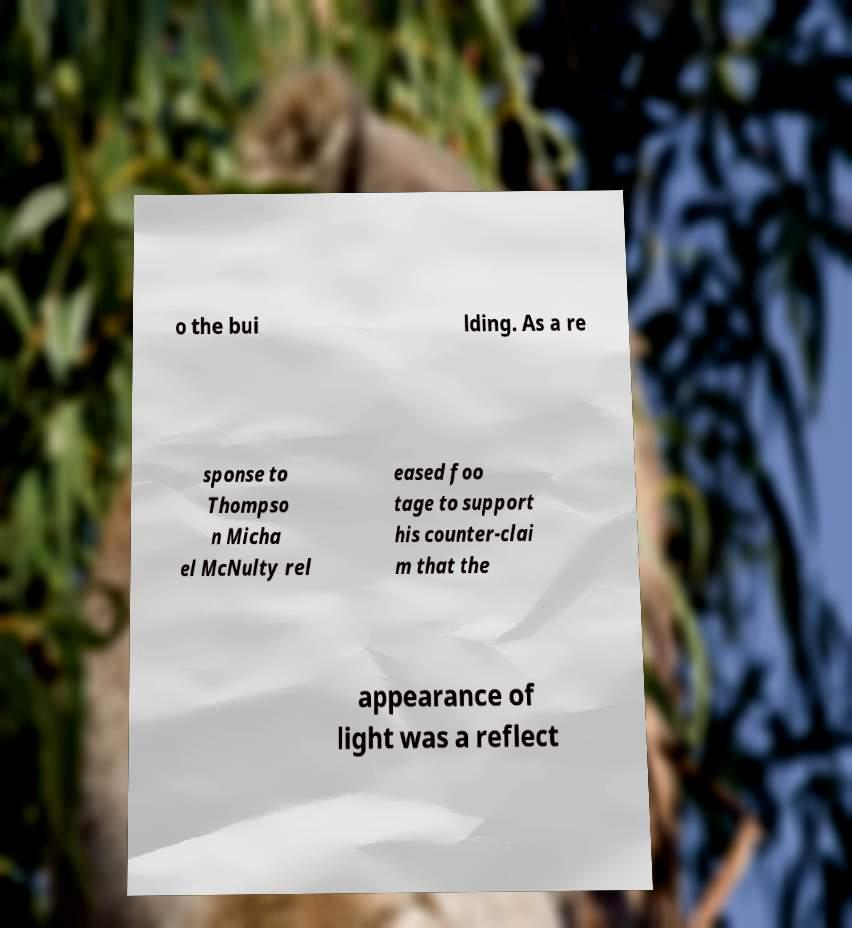For documentation purposes, I need the text within this image transcribed. Could you provide that? o the bui lding. As a re sponse to Thompso n Micha el McNulty rel eased foo tage to support his counter-clai m that the appearance of light was a reflect 